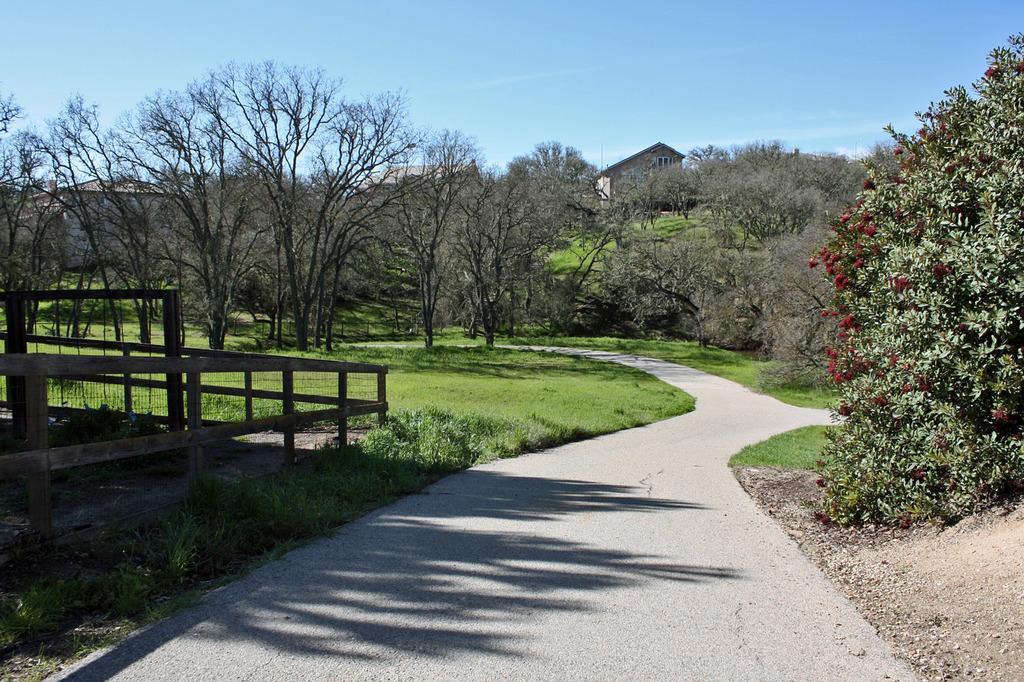Please provide a concise description of this image. In this image there is a path, on either side of the path there are trees, on the left side there is fencing, in the background are houses and blue sky. 